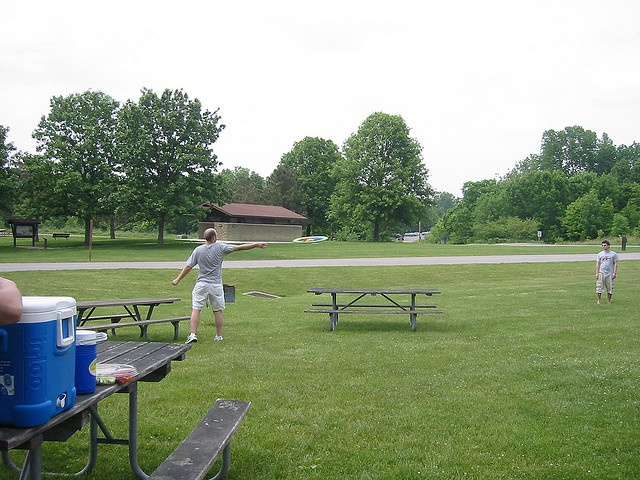Describe the objects in this image and their specific colors. I can see bench in white, gray, black, darkgreen, and darkgray tones, people in white, darkgray, gray, lightgray, and olive tones, bench in white, darkgray, black, gray, and olive tones, people in white, darkgray, gray, and lightgray tones, and people in white, darkgray, pink, black, and brown tones in this image. 